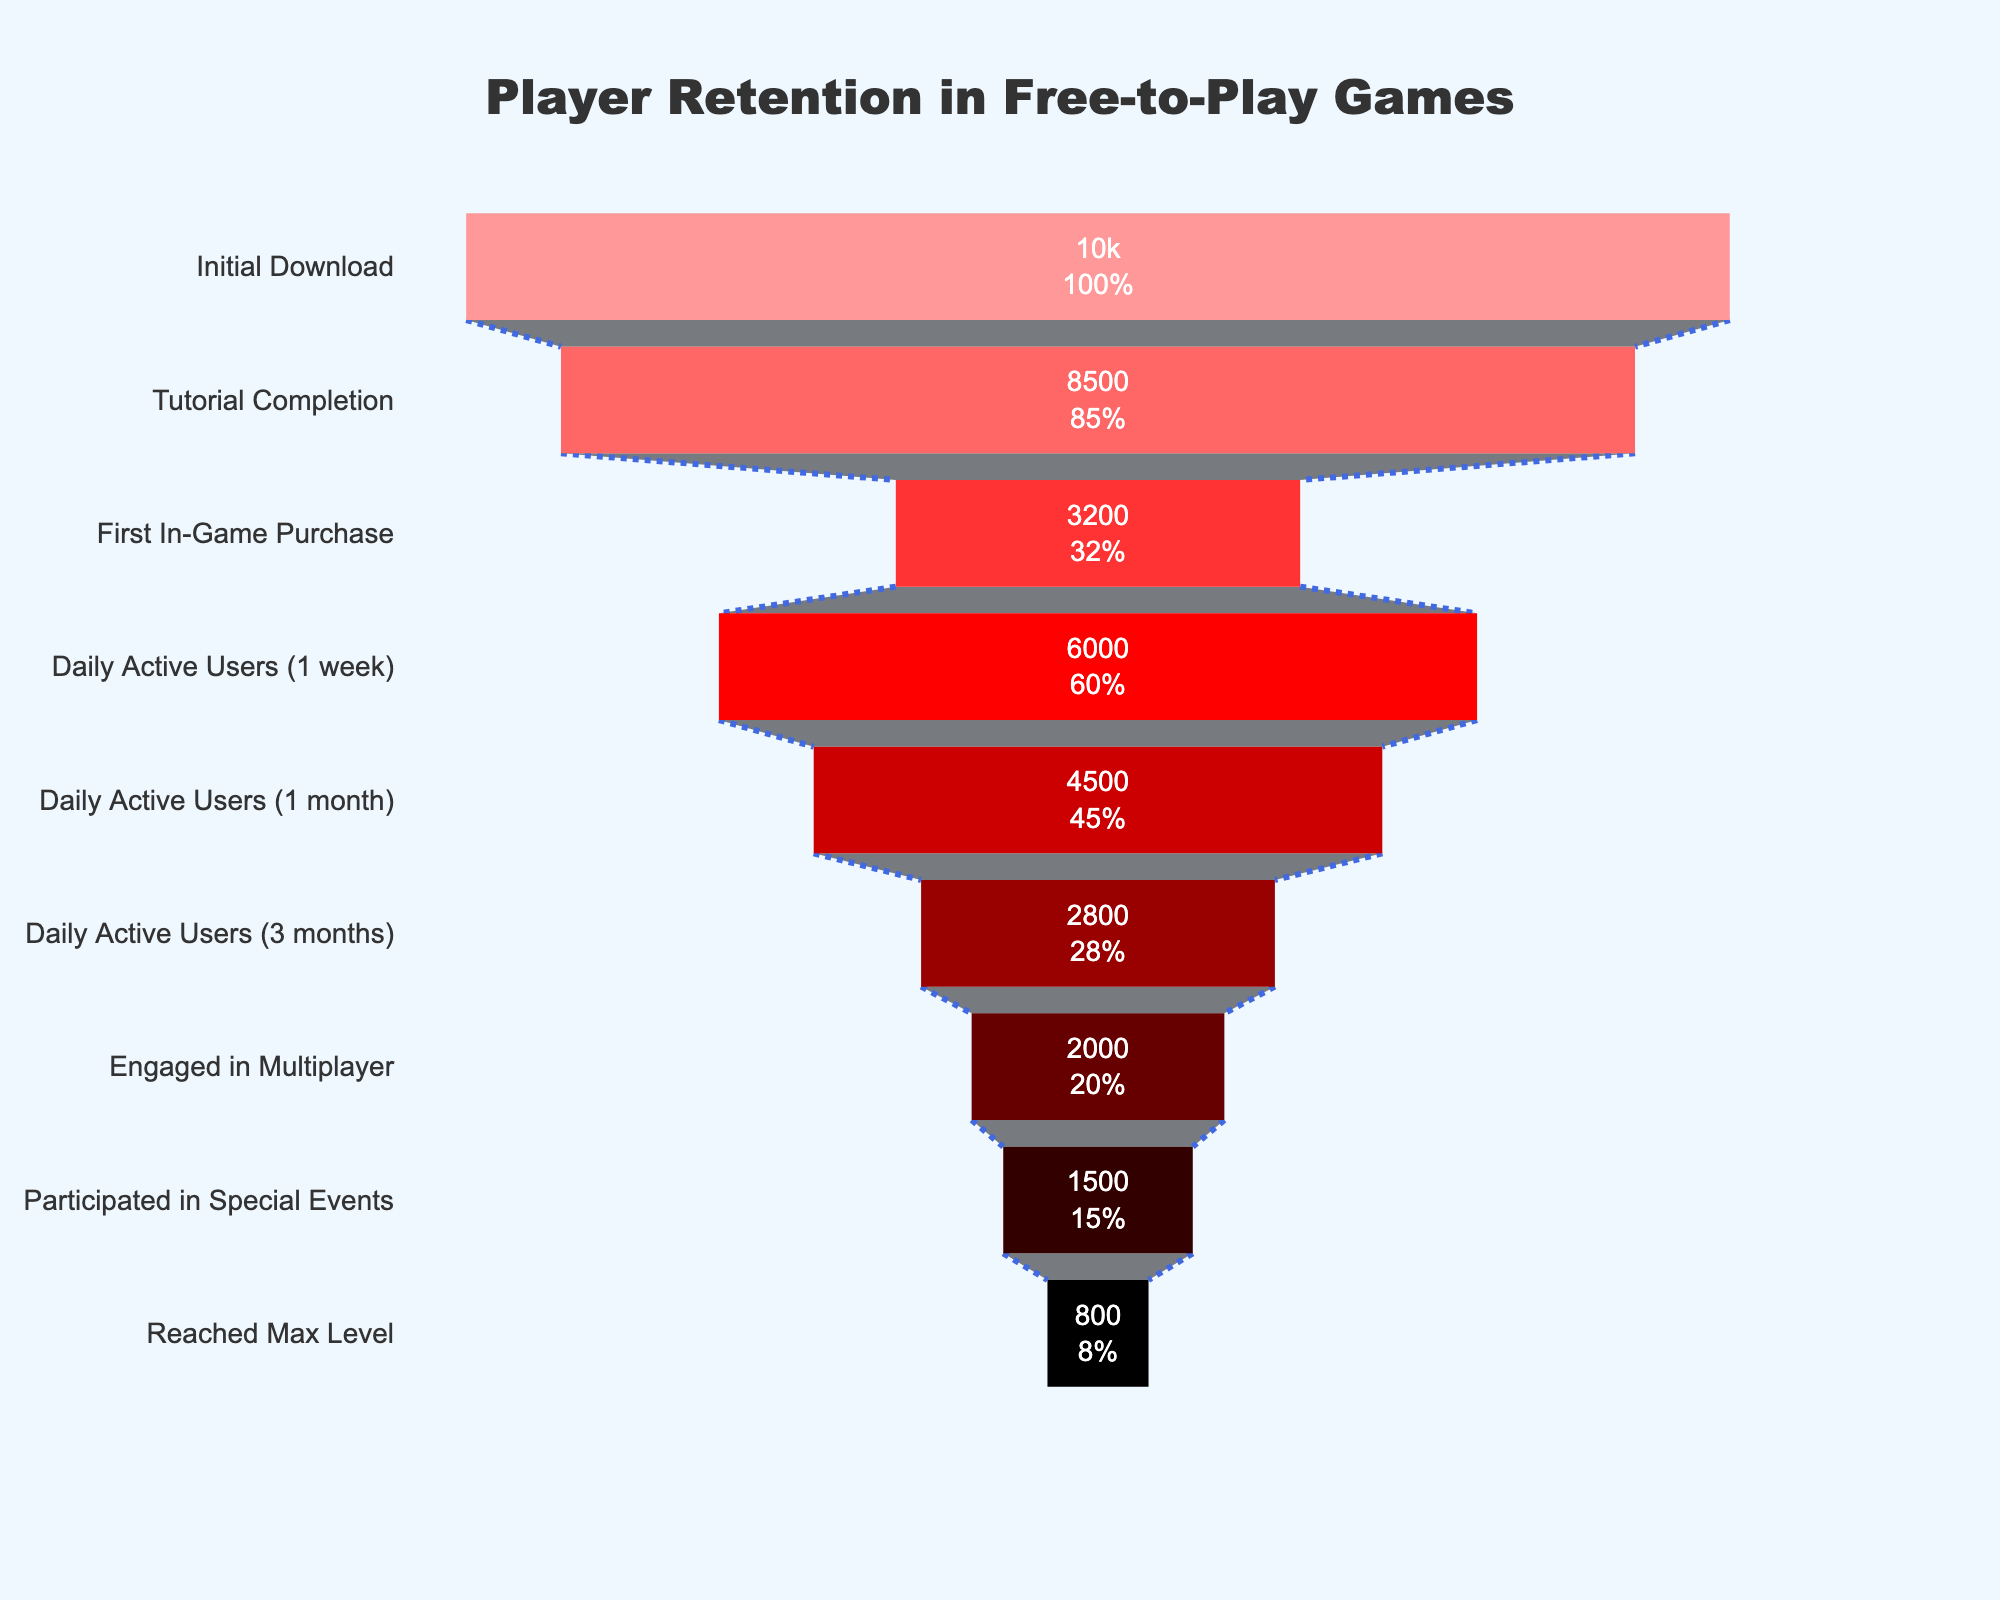What is the title of the chart? The title is displayed at the top-center of the chart. It reads "Player Retention in Free-to-Play Games".
Answer: Player Retention in Free-to-Play Games How many players completed the tutorial? We can find this information by looking at the "Tutorial Completion" stage in the funnel. It shows 8500 players.
Answer: 8500 Which stage has the highest drop-off in player count? By comparing the player counts between each stage, the largest drop-off is from "Tutorial Completion" (8500 players) to "First In-Game Purchase" (3200 players).
Answer: Tutorial Completion to First In-Game Purchase What percentage of players who downloaded the game reached max level? The initial download stage had 10,000 players, and the "Reached Max Level" stage had 800 players. To calculate the percentage, divide 800 by 10,000 and multiply by 100. 800 / 10000 * 100 = 8%.
Answer: 8% How many players are actively participating in special events after 3 months? The chart shows that 1500 players participated in special events.
Answer: 1500 What stage has the fewest number of players? The stage "Reached Max Level" shows the fewest players with 800.
Answer: Reached Max Level How many more players are engaged in multiplayer than those who reached max level? The "Engaged in Multiplayer" stage has 2000 players, and the "Reached Max Level" stage has 800 players. The difference is 2000 - 800 = 1200 players.
Answer: 1200 What's the difference in player count between those who completed the tutorial and those who made their first in-game purchase? The "Tutorial Completion" stage has 8500 players and "First In-Game Purchase" has 3200 players. The difference is 8500 - 3200 = 5300 players.
Answer: 5300 What fraction of players who completed the tutorial became Daily Active Users after one month? The "Tutorial Completion" stage has 8500 players, and the "Daily Active Users (1 month)" stage has 4500 players. The fraction is 4500 / 8500, which simplifies to approximately 0.53, or 53%.
Answer: 53% Which stage comes immediately after 'Daily Active Users (3 months)'? Looking at the stages in order, the stage immediately after "Daily Active Users (3 months)" is "Engaged in Multiplayer".
Answer: Engaged in Multiplayer 